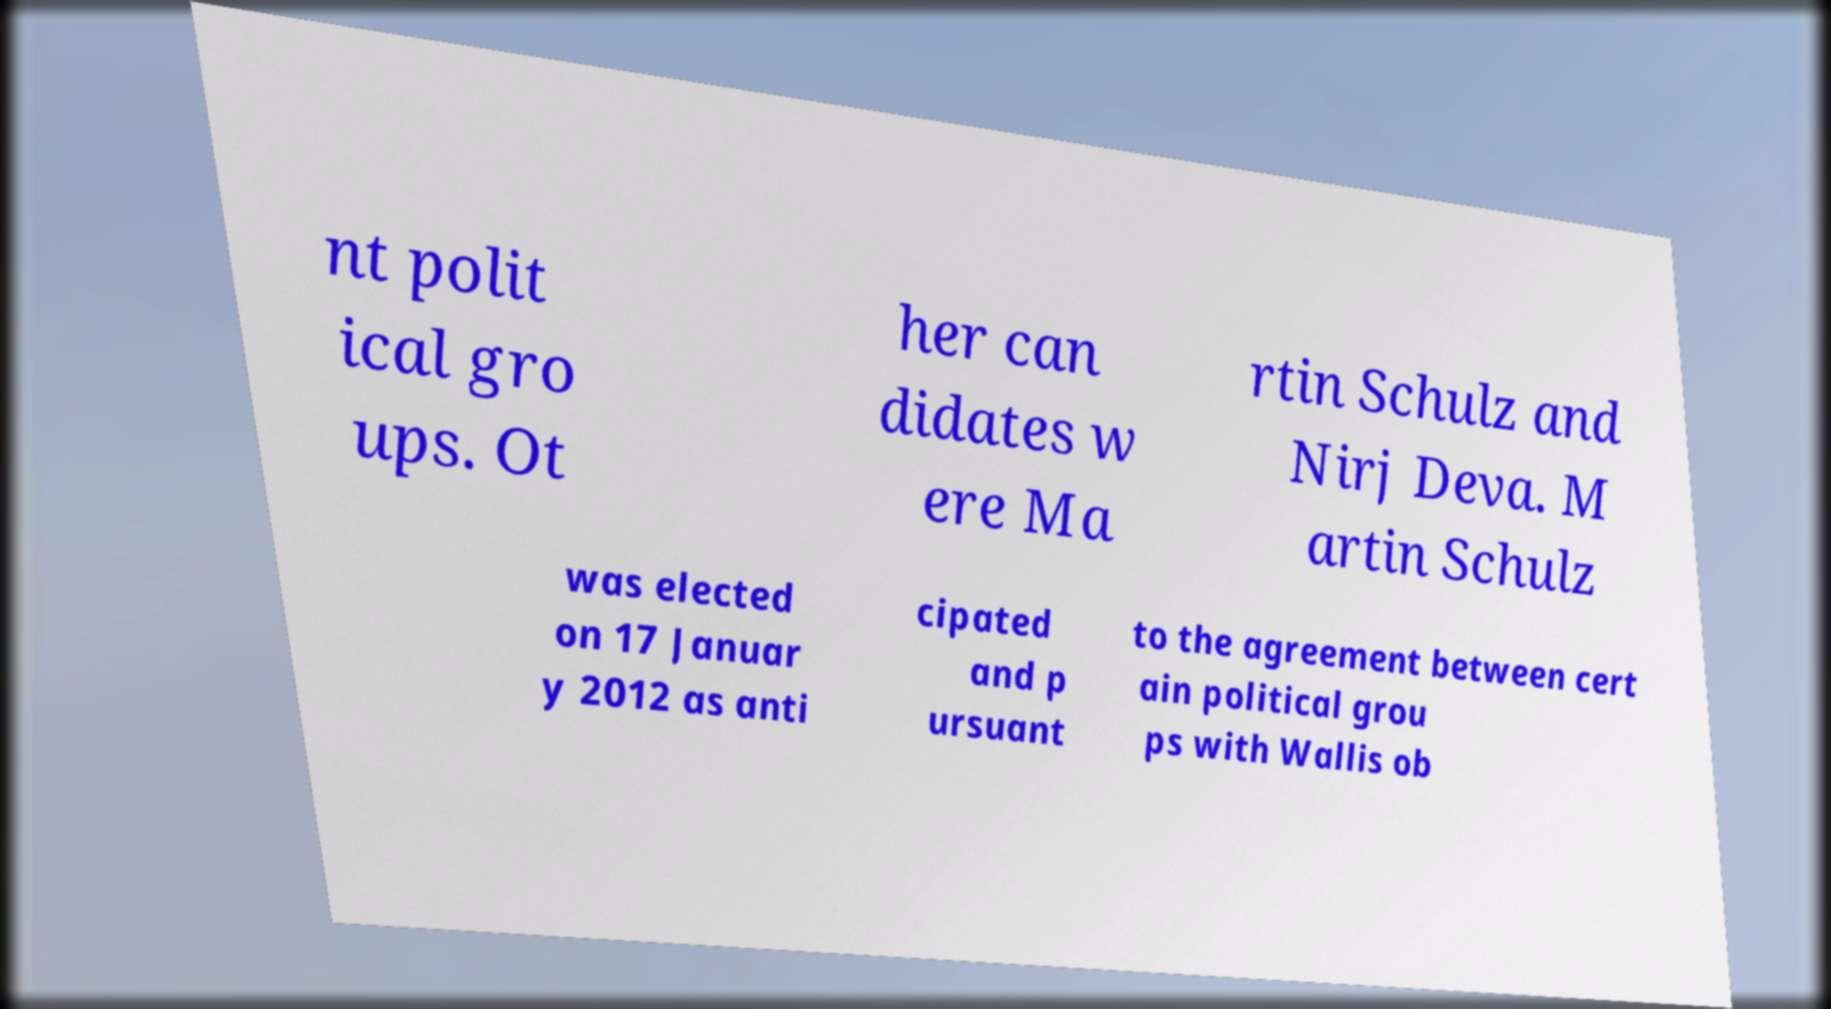Can you accurately transcribe the text from the provided image for me? nt polit ical gro ups. Ot her can didates w ere Ma rtin Schulz and Nirj Deva. M artin Schulz was elected on 17 Januar y 2012 as anti cipated and p ursuant to the agreement between cert ain political grou ps with Wallis ob 